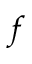<formula> <loc_0><loc_0><loc_500><loc_500>f</formula> 